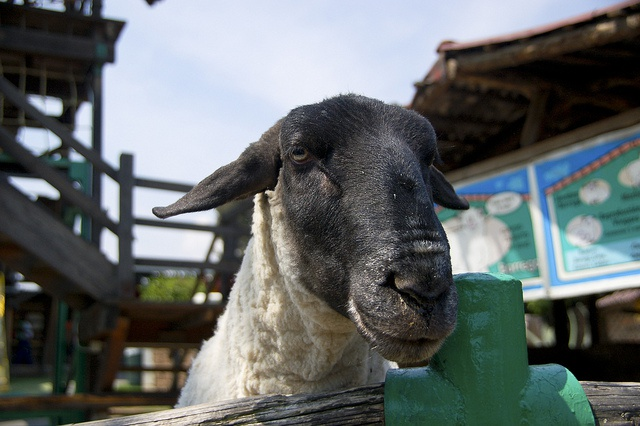Describe the objects in this image and their specific colors. I can see a sheep in gray, black, lightgray, and darkgray tones in this image. 